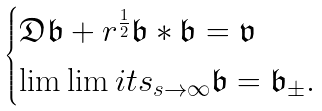<formula> <loc_0><loc_0><loc_500><loc_500>\begin{cases} \mathfrak { D } \mathfrak { b } + r ^ { \frac { 1 } { 2 } } \mathfrak { b } * \mathfrak { b } = \mathfrak { v } \\ \lim \lim i t s _ { s \to \infty } \mathfrak { b } = \mathfrak { b } _ { \pm } . \\ \end{cases}</formula> 